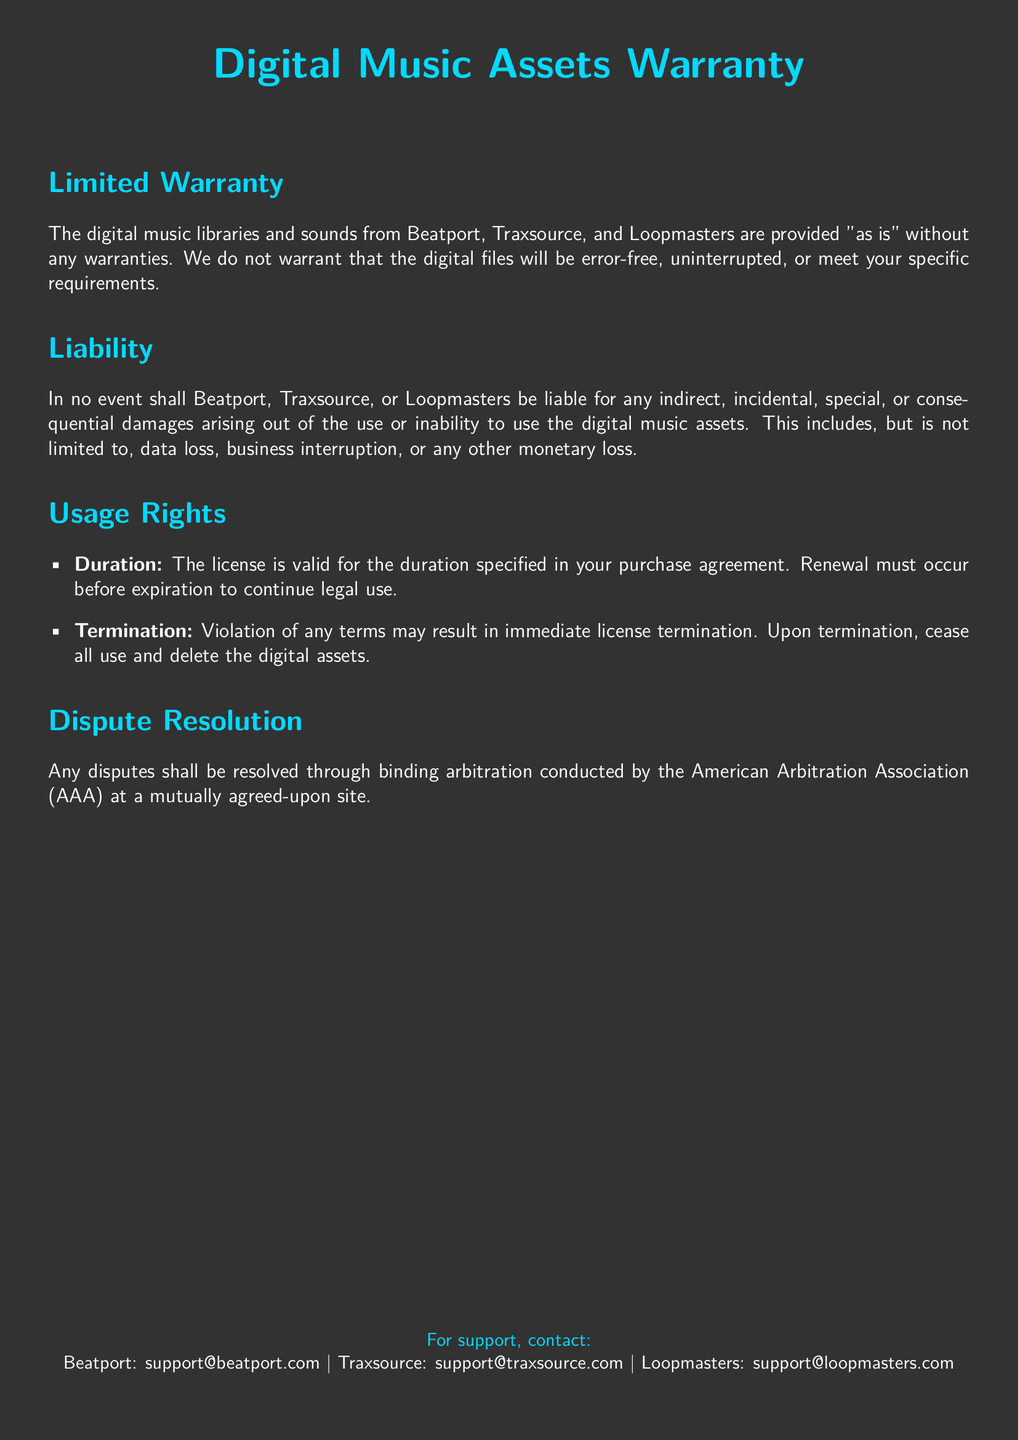what is the warranty for digital music assets? The warranty states that the digital music libraries and sounds are provided "as is" without any warranties.
Answer: "as is" what consequences arise from a violation of terms? The document states that violation of any terms may result in immediate license termination.
Answer: immediate license termination which arbitration association is mentioned for dispute resolution? The document specifies that disputes shall be resolved through binding arbitration conducted by the American Arbitration Association.
Answer: American Arbitration Association what must happen for continued legal use of the digital assets? According to the document, renewal must occur before expiration to continue legal use.
Answer: renewal must occur before expiration what types of damages are specified as not liable? The document mentions that there shall be no liability for indirect, incidental, special, or consequential damages.
Answer: indirect, incidental, special, or consequential damages 